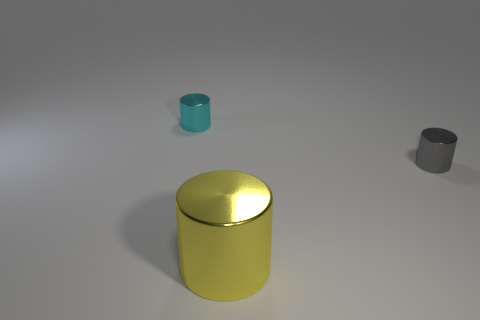Do the shiny cylinder that is behind the gray thing and the big metallic object have the same color?
Your answer should be very brief. No. There is a object that is on the right side of the cyan metallic cylinder and behind the yellow metal thing; what shape is it?
Your response must be concise. Cylinder. There is a small metallic thing that is in front of the cyan cylinder; what is its color?
Offer a terse response. Gray. Is there any other thing that is the same color as the big object?
Provide a succinct answer. No. Do the cyan metal object and the gray cylinder have the same size?
Provide a short and direct response. Yes. What size is the object that is left of the gray thing and behind the big yellow metallic object?
Make the answer very short. Small. What number of small objects have the same material as the cyan cylinder?
Offer a very short reply. 1. What color is the big object?
Make the answer very short. Yellow. There is a small object on the left side of the small gray shiny cylinder; is its shape the same as the gray metallic thing?
Ensure brevity in your answer.  Yes. How many things are either shiny cylinders right of the cyan cylinder or small cyan shiny cylinders?
Offer a terse response. 3. 